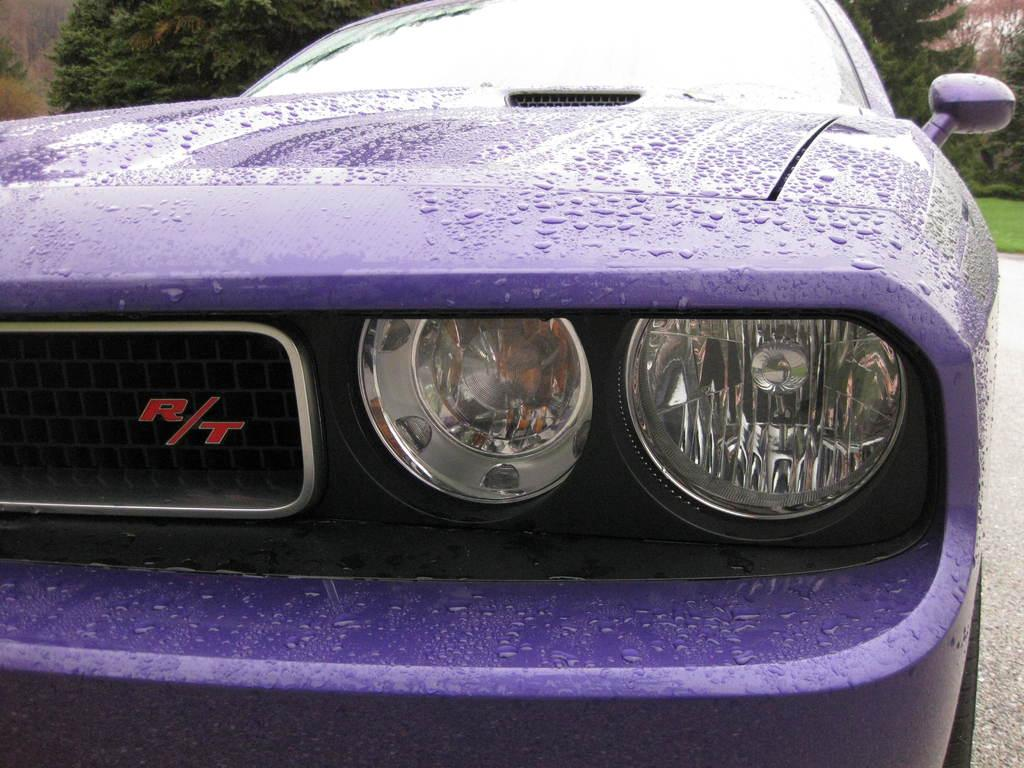What is the main subject of the image? There is a car on the road in the image. What can be seen in the background of the image? Trees and grass are visible in the background of the image. What type of lip can be seen on the car in the image? There is no lip present on the car in the image. How does the car rest on the road in the image? The car is not resting in the image; it is moving on the road. 